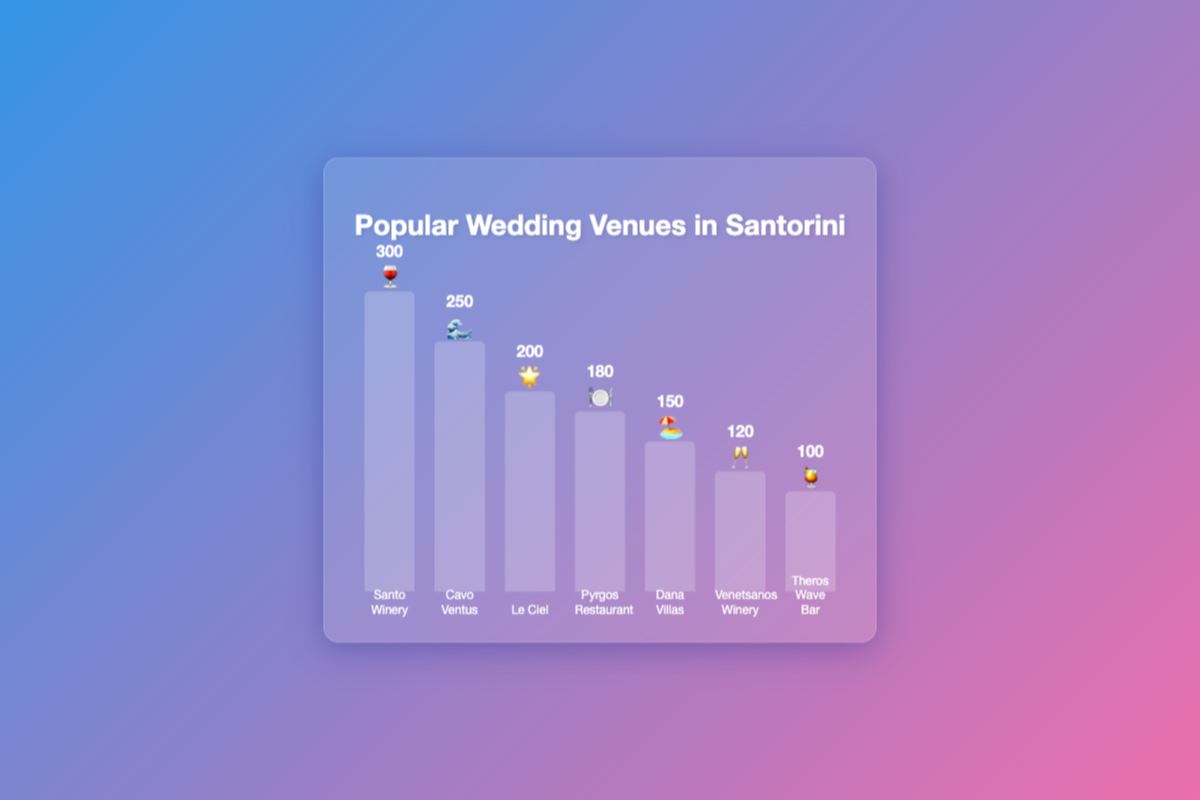Which wedding venue has the highest guest capacity? By inspecting the heights of the bars and the capacity labels above them in the chart, you can see the highest bar belongs to Santo Winery with a capacity of 300 guests.
Answer: Santo Winery Which venue has the capacity to accommodate 100 people? By looking at the capacity labels, we find that Theros Wave Bar has a capacity of 100 guests as indicated by the shortest bar in the chart.
Answer: Theros Wave Bar What is the combined capacity of Cavo Ventus and Dana Villas? First identify the capacities of Cavo Ventus and Dana Villas from the labels (250 and 150, respectively). Add these two values together: 250 + 150 = 400.
Answer: 400 Which venue hosts fewer guests: Venetsanos Winery or Pyrgos Restaurant? Compare the capacities shown in the labels for Venetsanos Winery (120) and Pyrgos Restaurant (180). Venetsanos Winery hosts fewer guests.
Answer: Venetsanos Winery How many venues have a capacity of less than 150? Identify the bars with capacities less than 150: Venetsanos Winery (120) and Theros Wave Bar (100). Two venues meet this criterion.
Answer: 2 What is the difference in capacity between the venue with the highest and the one with the lowest capacity? Identify the highest capacity (Santo Winery at 300) and the lowest capacity (Theros Wave Bar at 100). Subtract the lowest from the highest: 300 - 100 = 200.
Answer: 200 Which 3 venues in the chart have the highest guest capacities? By comparing the heights of the bars, you can see that the top three venues with the highest capacities are Santo Winery (300), Cavo Ventus (250), and Le Ciel (200).
Answer: Santo Winery, Cavo Ventus, Le Ciel What is the average guest capacity of all the listed venues? Sum all the capacities: 300 + 250 + 200 + 180 + 150 + 120 + 100 = 1300. Then, divide by the number of venues (7) to find the average: 1300 / 7 ≈ 186.
Answer: 186 What are the emojis used for depicting the venues Dana Villas and Venetsanos Winery? By checking the emojis next to the bar labels, Dana Villas is represented by 🏖️ and Venetsanos Winery by 🥂.
Answer: 🏖️, 🥂 Which venue has a capacity closest to 200 guests? From the labels, Le Ciel has a capacity of 200 guests, which is exactly 200 and not just close.
Answer: Le Ciel 